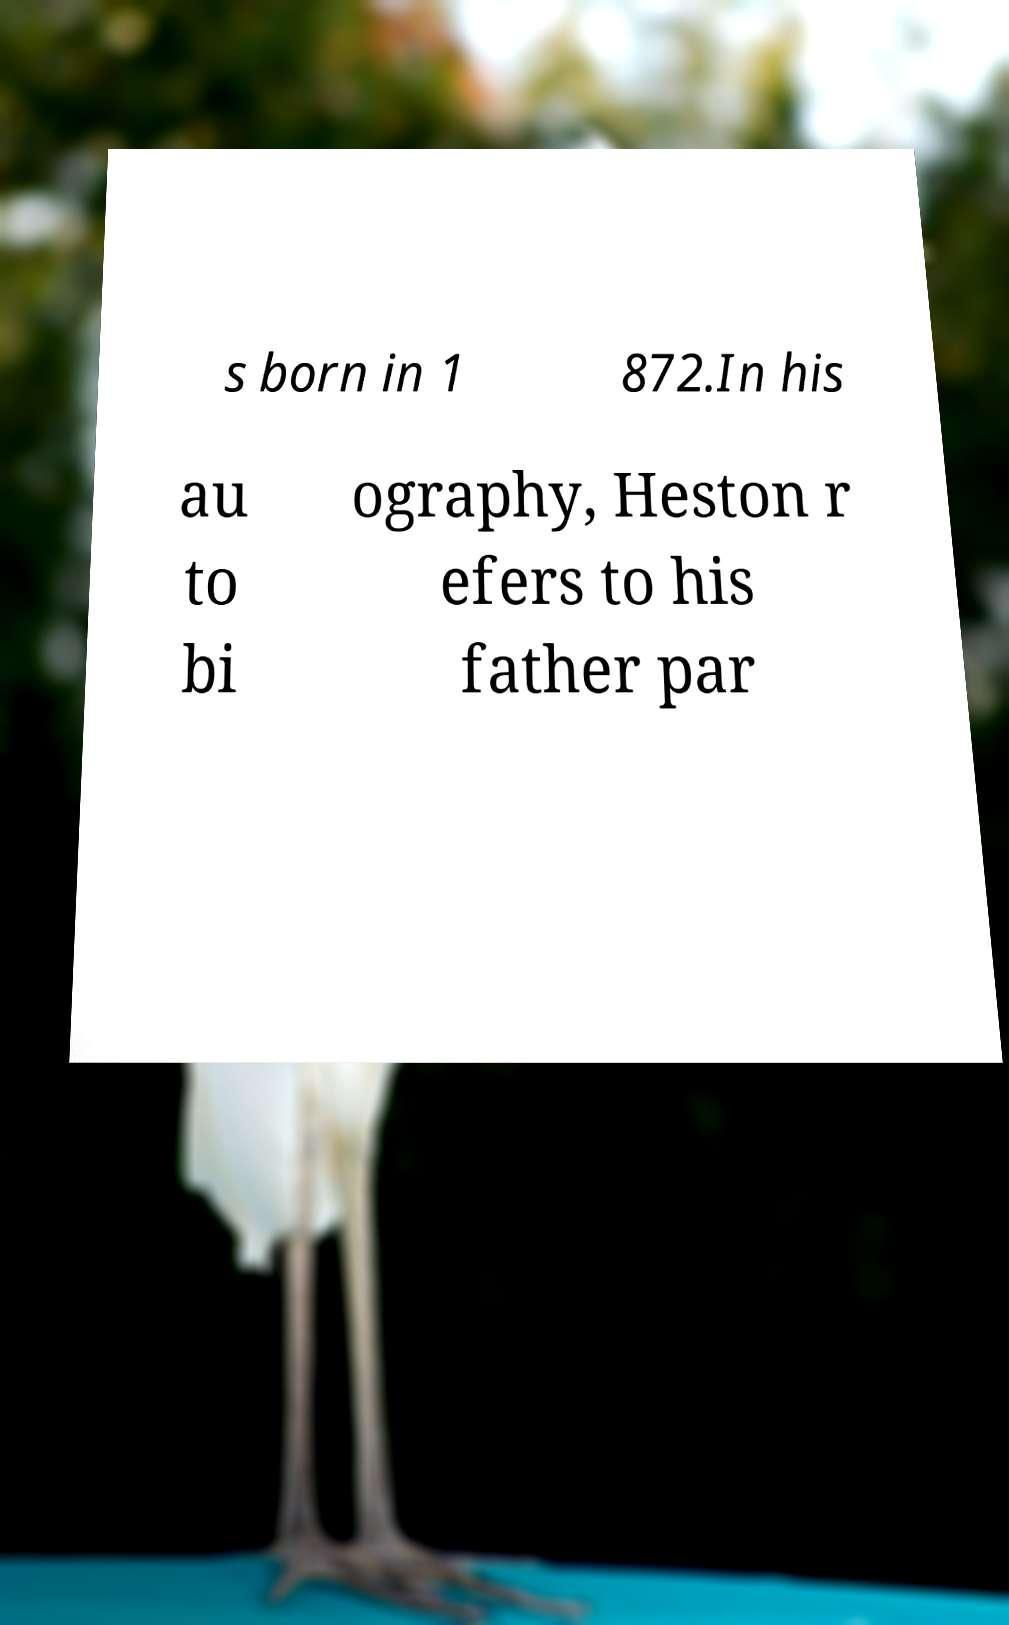Please read and relay the text visible in this image. What does it say? s born in 1 872.In his au to bi ography, Heston r efers to his father par 